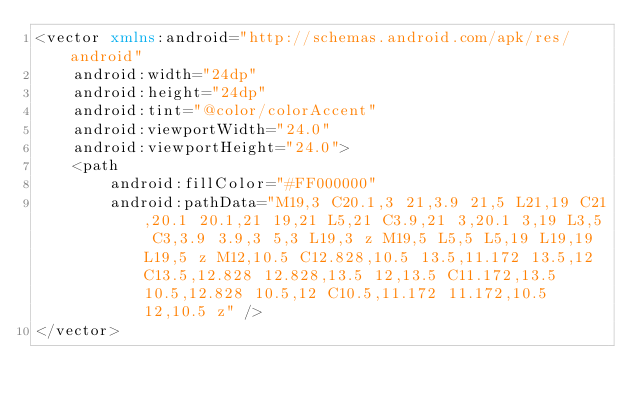Convert code to text. <code><loc_0><loc_0><loc_500><loc_500><_XML_><vector xmlns:android="http://schemas.android.com/apk/res/android"
    android:width="24dp"
    android:height="24dp"
    android:tint="@color/colorAccent"
    android:viewportWidth="24.0"
    android:viewportHeight="24.0">
    <path
        android:fillColor="#FF000000"
        android:pathData="M19,3 C20.1,3 21,3.9 21,5 L21,19 C21,20.1 20.1,21 19,21 L5,21 C3.9,21 3,20.1 3,19 L3,5 C3,3.9 3.9,3 5,3 L19,3 z M19,5 L5,5 L5,19 L19,19 L19,5 z M12,10.5 C12.828,10.5 13.5,11.172 13.5,12 C13.5,12.828 12.828,13.5 12,13.5 C11.172,13.5 10.5,12.828 10.5,12 C10.5,11.172 11.172,10.5 12,10.5 z" />
</vector>
</code> 